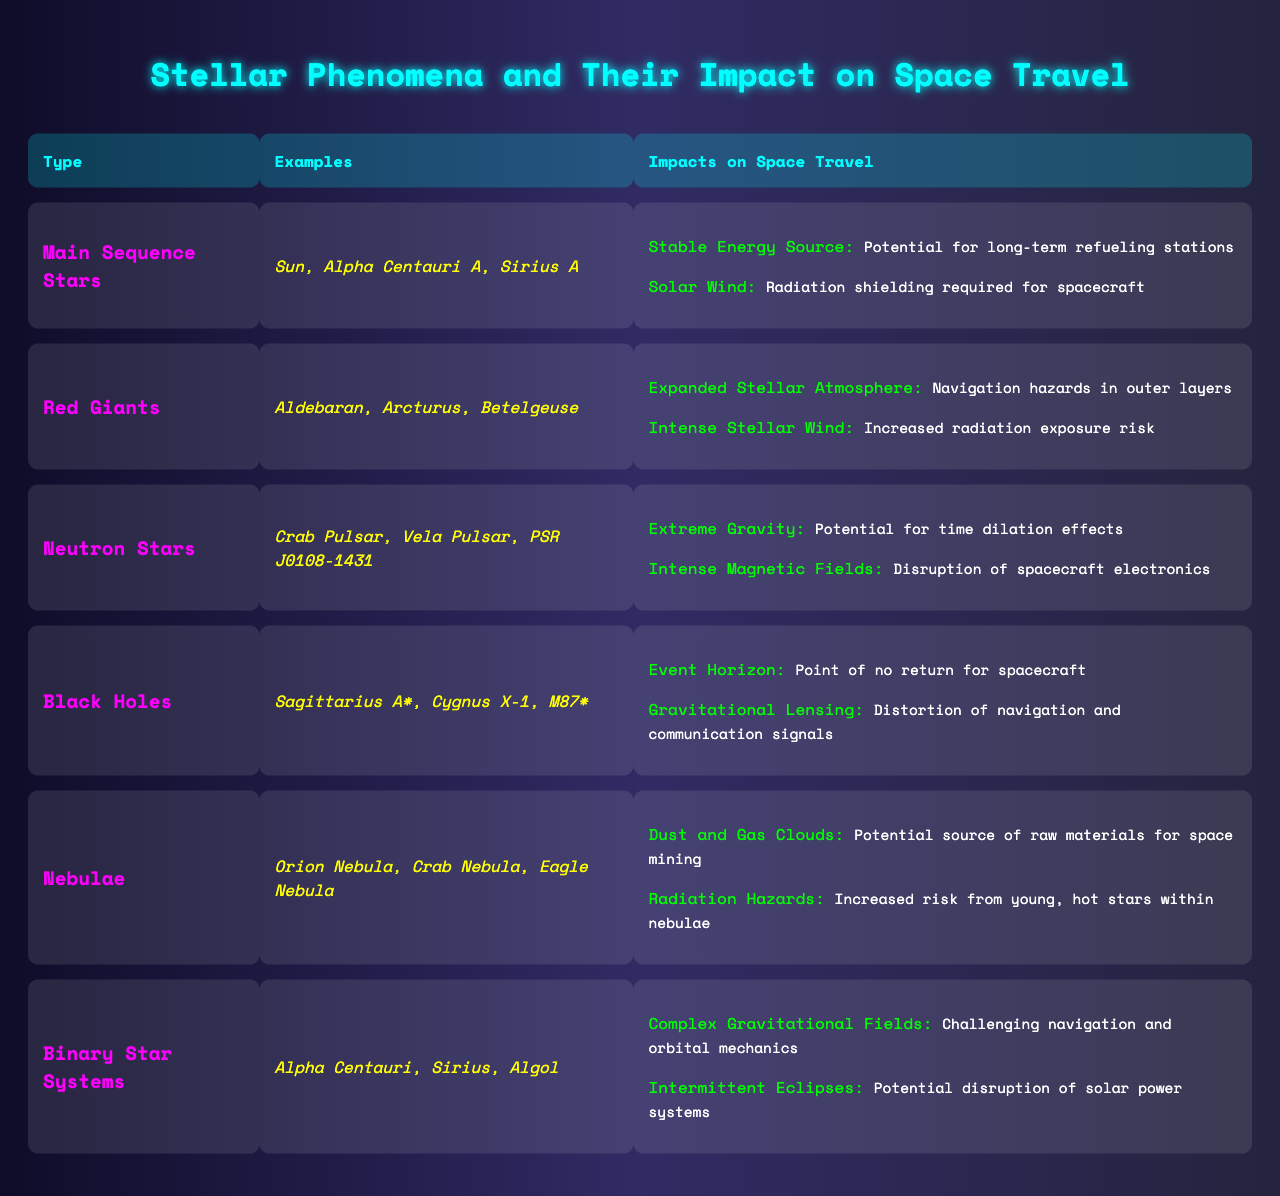What are some examples of Main Sequence Stars? The table lists the examples of Main Sequence Stars under the "Examples" column for that type. These include the Sun, Alpha Centauri A, and Sirius A.
Answer: Sun, Alpha Centauri A, Sirius A What is the impact of Red Giants on space travel? The table provides impacts for Red Giants under the "Impacts on Space Travel" column. It states that Red Giants have an expanded stellar atmosphere that poses navigation hazards and intense stellar wind that increases radiation exposure risk.
Answer: Navigation hazards; Increased radiation exposure risk How many impacts are listed for Neutron Stars? A count of the impacts listed under Neutron Stars in the table will show the number of impacts. Neutron Stars have two impacts listed: extreme gravity and intense magnetic fields.
Answer: 2 Are Black Holes known to pose risks to spacecraft? The table indicates that Black Holes have two impacts listed that indicate risks to spacecraft: the event horizon presents a point of no return, and gravitational lensing distorts navigation and communication signals. Therefore, yes, they pose risks.
Answer: Yes Which stellar type has the highest number of examples listed? The table shows that both Main Sequence Stars and Binary Star Systems have three examples listed. Thus, they are tied for the highest number of examples.
Answer: Main Sequence Stars and Binary Star Systems What is the difference in potential impacts between Binary Star Systems and Main Sequence Stars? The table outlines that Binary Star Systems have complex gravitational fields that affect navigation and potential disruptions due to intermittent eclipses, whereas Main Sequence Stars provide stable energy sources and require radiation shielding due to solar winds. This shows a distinct difference in their nature of impacts.
Answer: Different nature of impacts Which stellar phenomenon has an impact described as “Point of no return for spacecraft”? The impact mentioned corresponds to Black Holes, specifically the impact of the event horizon as outlined in the table, which describes it as the point of no return for spacecraft.
Answer: Black Holes If one were to travel through nebulae, what risks should be considered? The table indicates two risks associated with traveling through nebulae: dust and gas clouds as navigation obstacles and radiation hazards due to young, hot stars within those nebulae.
Answer: Dust and gas clouds; Radiation hazards Which stellar types have a direct relation to increased radiation exposure risks? The table states that both Red Giants and Neutron Stars are associated with increased radiation risks; Red Giants have intense stellar wind risk and Neutron Stars have intense magnetic fields, indicating heightened exposure risks overall.
Answer: Red Giants and Neutron Stars How does the impact of Neutron Stars relate to space-time concepts? The table describes how Neutron Stars pose extreme gravity, which can result in time dilation effects, a concept directly related to space-time in physics. Thus, their impact indicates a relationship to time concepts in space travel.
Answer: Space-time concepts through time dilation effects 